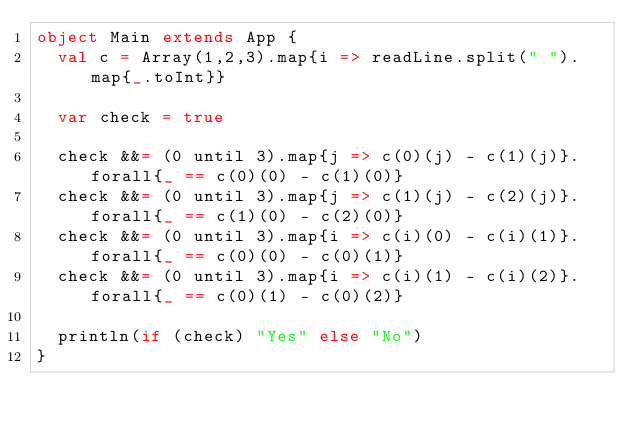<code> <loc_0><loc_0><loc_500><loc_500><_Scala_>object Main extends App {
  val c = Array(1,2,3).map{i => readLine.split(" ").map{_.toInt}}
  
  var check = true
  
  check &&= (0 until 3).map{j => c(0)(j) - c(1)(j)}.forall{_ == c(0)(0) - c(1)(0)}
  check &&= (0 until 3).map{j => c(1)(j) - c(2)(j)}.forall{_ == c(1)(0) - c(2)(0)}
  check &&= (0 until 3).map{i => c(i)(0) - c(i)(1)}.forall{_ == c(0)(0) - c(0)(1)}
  check &&= (0 until 3).map{i => c(i)(1) - c(i)(2)}.forall{_ == c(0)(1) - c(0)(2)}
  
  println(if (check) "Yes" else "No")
}</code> 